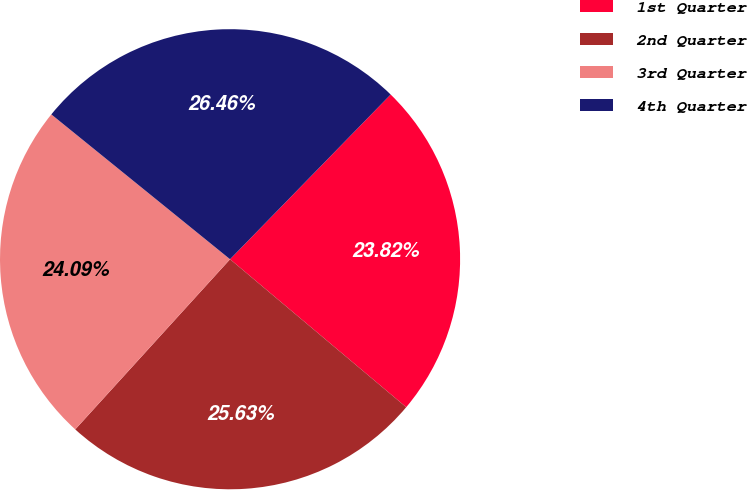Convert chart to OTSL. <chart><loc_0><loc_0><loc_500><loc_500><pie_chart><fcel>1st Quarter<fcel>2nd Quarter<fcel>3rd Quarter<fcel>4th Quarter<nl><fcel>23.82%<fcel>25.63%<fcel>24.09%<fcel>26.46%<nl></chart> 